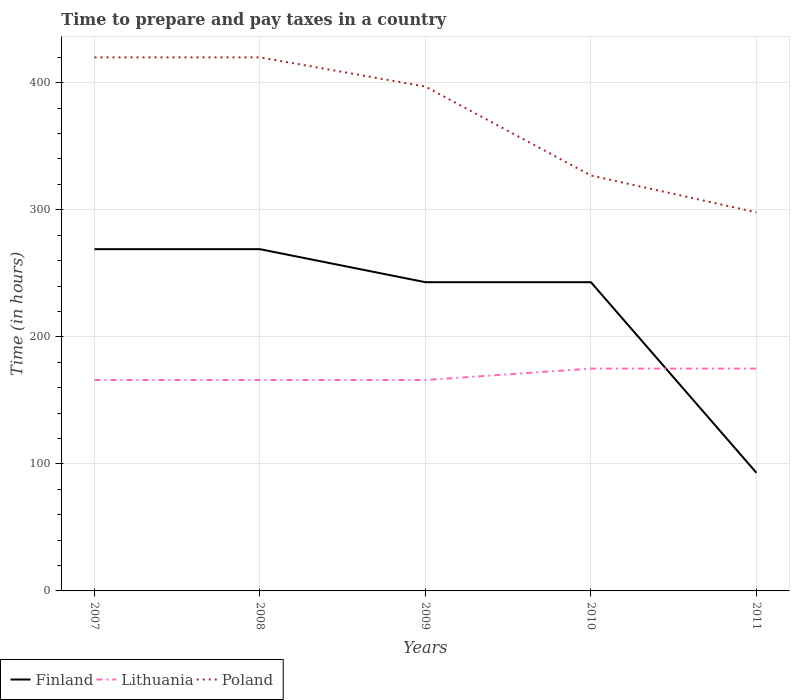How many different coloured lines are there?
Ensure brevity in your answer.  3. Across all years, what is the maximum number of hours required to prepare and pay taxes in Poland?
Keep it short and to the point. 298. In which year was the number of hours required to prepare and pay taxes in Finland maximum?
Your response must be concise. 2011. What is the total number of hours required to prepare and pay taxes in Finland in the graph?
Keep it short and to the point. 0. What is the difference between the highest and the second highest number of hours required to prepare and pay taxes in Poland?
Your response must be concise. 122. What is the difference between the highest and the lowest number of hours required to prepare and pay taxes in Finland?
Keep it short and to the point. 4. How many years are there in the graph?
Keep it short and to the point. 5. Does the graph contain grids?
Offer a terse response. Yes. Where does the legend appear in the graph?
Your answer should be compact. Bottom left. How many legend labels are there?
Ensure brevity in your answer.  3. How are the legend labels stacked?
Your answer should be compact. Horizontal. What is the title of the graph?
Give a very brief answer. Time to prepare and pay taxes in a country. What is the label or title of the X-axis?
Your answer should be compact. Years. What is the label or title of the Y-axis?
Provide a succinct answer. Time (in hours). What is the Time (in hours) in Finland in 2007?
Provide a succinct answer. 269. What is the Time (in hours) of Lithuania in 2007?
Your answer should be very brief. 166. What is the Time (in hours) of Poland in 2007?
Keep it short and to the point. 420. What is the Time (in hours) in Finland in 2008?
Keep it short and to the point. 269. What is the Time (in hours) of Lithuania in 2008?
Your response must be concise. 166. What is the Time (in hours) in Poland in 2008?
Your answer should be very brief. 420. What is the Time (in hours) of Finland in 2009?
Ensure brevity in your answer.  243. What is the Time (in hours) of Lithuania in 2009?
Make the answer very short. 166. What is the Time (in hours) of Poland in 2009?
Offer a very short reply. 397. What is the Time (in hours) of Finland in 2010?
Provide a succinct answer. 243. What is the Time (in hours) in Lithuania in 2010?
Ensure brevity in your answer.  175. What is the Time (in hours) of Poland in 2010?
Give a very brief answer. 327. What is the Time (in hours) of Finland in 2011?
Offer a very short reply. 93. What is the Time (in hours) in Lithuania in 2011?
Your answer should be compact. 175. What is the Time (in hours) in Poland in 2011?
Your response must be concise. 298. Across all years, what is the maximum Time (in hours) in Finland?
Provide a short and direct response. 269. Across all years, what is the maximum Time (in hours) in Lithuania?
Your response must be concise. 175. Across all years, what is the maximum Time (in hours) of Poland?
Your response must be concise. 420. Across all years, what is the minimum Time (in hours) of Finland?
Provide a succinct answer. 93. Across all years, what is the minimum Time (in hours) of Lithuania?
Your response must be concise. 166. Across all years, what is the minimum Time (in hours) in Poland?
Provide a short and direct response. 298. What is the total Time (in hours) of Finland in the graph?
Your response must be concise. 1117. What is the total Time (in hours) of Lithuania in the graph?
Provide a short and direct response. 848. What is the total Time (in hours) in Poland in the graph?
Ensure brevity in your answer.  1862. What is the difference between the Time (in hours) in Finland in 2007 and that in 2008?
Offer a terse response. 0. What is the difference between the Time (in hours) of Finland in 2007 and that in 2009?
Keep it short and to the point. 26. What is the difference between the Time (in hours) of Poland in 2007 and that in 2009?
Make the answer very short. 23. What is the difference between the Time (in hours) of Finland in 2007 and that in 2010?
Your answer should be very brief. 26. What is the difference between the Time (in hours) of Lithuania in 2007 and that in 2010?
Your answer should be compact. -9. What is the difference between the Time (in hours) in Poland in 2007 and that in 2010?
Offer a very short reply. 93. What is the difference between the Time (in hours) in Finland in 2007 and that in 2011?
Provide a short and direct response. 176. What is the difference between the Time (in hours) in Lithuania in 2007 and that in 2011?
Provide a succinct answer. -9. What is the difference between the Time (in hours) of Poland in 2007 and that in 2011?
Your response must be concise. 122. What is the difference between the Time (in hours) in Poland in 2008 and that in 2009?
Keep it short and to the point. 23. What is the difference between the Time (in hours) in Finland in 2008 and that in 2010?
Your response must be concise. 26. What is the difference between the Time (in hours) of Lithuania in 2008 and that in 2010?
Provide a succinct answer. -9. What is the difference between the Time (in hours) in Poland in 2008 and that in 2010?
Your answer should be compact. 93. What is the difference between the Time (in hours) in Finland in 2008 and that in 2011?
Provide a short and direct response. 176. What is the difference between the Time (in hours) in Poland in 2008 and that in 2011?
Give a very brief answer. 122. What is the difference between the Time (in hours) in Finland in 2009 and that in 2010?
Your answer should be very brief. 0. What is the difference between the Time (in hours) of Lithuania in 2009 and that in 2010?
Keep it short and to the point. -9. What is the difference between the Time (in hours) in Poland in 2009 and that in 2010?
Give a very brief answer. 70. What is the difference between the Time (in hours) of Finland in 2009 and that in 2011?
Make the answer very short. 150. What is the difference between the Time (in hours) of Lithuania in 2009 and that in 2011?
Offer a terse response. -9. What is the difference between the Time (in hours) in Finland in 2010 and that in 2011?
Your answer should be compact. 150. What is the difference between the Time (in hours) in Poland in 2010 and that in 2011?
Offer a very short reply. 29. What is the difference between the Time (in hours) of Finland in 2007 and the Time (in hours) of Lithuania in 2008?
Give a very brief answer. 103. What is the difference between the Time (in hours) of Finland in 2007 and the Time (in hours) of Poland in 2008?
Your answer should be compact. -151. What is the difference between the Time (in hours) of Lithuania in 2007 and the Time (in hours) of Poland in 2008?
Offer a terse response. -254. What is the difference between the Time (in hours) of Finland in 2007 and the Time (in hours) of Lithuania in 2009?
Your answer should be very brief. 103. What is the difference between the Time (in hours) in Finland in 2007 and the Time (in hours) in Poland in 2009?
Make the answer very short. -128. What is the difference between the Time (in hours) in Lithuania in 2007 and the Time (in hours) in Poland in 2009?
Give a very brief answer. -231. What is the difference between the Time (in hours) of Finland in 2007 and the Time (in hours) of Lithuania in 2010?
Provide a succinct answer. 94. What is the difference between the Time (in hours) in Finland in 2007 and the Time (in hours) in Poland in 2010?
Your answer should be very brief. -58. What is the difference between the Time (in hours) of Lithuania in 2007 and the Time (in hours) of Poland in 2010?
Ensure brevity in your answer.  -161. What is the difference between the Time (in hours) of Finland in 2007 and the Time (in hours) of Lithuania in 2011?
Give a very brief answer. 94. What is the difference between the Time (in hours) of Finland in 2007 and the Time (in hours) of Poland in 2011?
Provide a short and direct response. -29. What is the difference between the Time (in hours) of Lithuania in 2007 and the Time (in hours) of Poland in 2011?
Provide a short and direct response. -132. What is the difference between the Time (in hours) in Finland in 2008 and the Time (in hours) in Lithuania in 2009?
Provide a short and direct response. 103. What is the difference between the Time (in hours) of Finland in 2008 and the Time (in hours) of Poland in 2009?
Provide a succinct answer. -128. What is the difference between the Time (in hours) in Lithuania in 2008 and the Time (in hours) in Poland in 2009?
Offer a very short reply. -231. What is the difference between the Time (in hours) in Finland in 2008 and the Time (in hours) in Lithuania in 2010?
Keep it short and to the point. 94. What is the difference between the Time (in hours) of Finland in 2008 and the Time (in hours) of Poland in 2010?
Offer a terse response. -58. What is the difference between the Time (in hours) of Lithuania in 2008 and the Time (in hours) of Poland in 2010?
Keep it short and to the point. -161. What is the difference between the Time (in hours) of Finland in 2008 and the Time (in hours) of Lithuania in 2011?
Your answer should be compact. 94. What is the difference between the Time (in hours) of Lithuania in 2008 and the Time (in hours) of Poland in 2011?
Make the answer very short. -132. What is the difference between the Time (in hours) of Finland in 2009 and the Time (in hours) of Poland in 2010?
Offer a very short reply. -84. What is the difference between the Time (in hours) in Lithuania in 2009 and the Time (in hours) in Poland in 2010?
Offer a terse response. -161. What is the difference between the Time (in hours) of Finland in 2009 and the Time (in hours) of Poland in 2011?
Your answer should be very brief. -55. What is the difference between the Time (in hours) of Lithuania in 2009 and the Time (in hours) of Poland in 2011?
Keep it short and to the point. -132. What is the difference between the Time (in hours) of Finland in 2010 and the Time (in hours) of Lithuania in 2011?
Ensure brevity in your answer.  68. What is the difference between the Time (in hours) in Finland in 2010 and the Time (in hours) in Poland in 2011?
Provide a short and direct response. -55. What is the difference between the Time (in hours) of Lithuania in 2010 and the Time (in hours) of Poland in 2011?
Keep it short and to the point. -123. What is the average Time (in hours) in Finland per year?
Your answer should be very brief. 223.4. What is the average Time (in hours) of Lithuania per year?
Keep it short and to the point. 169.6. What is the average Time (in hours) in Poland per year?
Offer a terse response. 372.4. In the year 2007, what is the difference between the Time (in hours) of Finland and Time (in hours) of Lithuania?
Your response must be concise. 103. In the year 2007, what is the difference between the Time (in hours) in Finland and Time (in hours) in Poland?
Make the answer very short. -151. In the year 2007, what is the difference between the Time (in hours) of Lithuania and Time (in hours) of Poland?
Keep it short and to the point. -254. In the year 2008, what is the difference between the Time (in hours) of Finland and Time (in hours) of Lithuania?
Your answer should be compact. 103. In the year 2008, what is the difference between the Time (in hours) of Finland and Time (in hours) of Poland?
Provide a short and direct response. -151. In the year 2008, what is the difference between the Time (in hours) of Lithuania and Time (in hours) of Poland?
Your answer should be compact. -254. In the year 2009, what is the difference between the Time (in hours) in Finland and Time (in hours) in Lithuania?
Ensure brevity in your answer.  77. In the year 2009, what is the difference between the Time (in hours) of Finland and Time (in hours) of Poland?
Offer a terse response. -154. In the year 2009, what is the difference between the Time (in hours) in Lithuania and Time (in hours) in Poland?
Provide a succinct answer. -231. In the year 2010, what is the difference between the Time (in hours) of Finland and Time (in hours) of Lithuania?
Your answer should be compact. 68. In the year 2010, what is the difference between the Time (in hours) in Finland and Time (in hours) in Poland?
Provide a short and direct response. -84. In the year 2010, what is the difference between the Time (in hours) in Lithuania and Time (in hours) in Poland?
Ensure brevity in your answer.  -152. In the year 2011, what is the difference between the Time (in hours) in Finland and Time (in hours) in Lithuania?
Give a very brief answer. -82. In the year 2011, what is the difference between the Time (in hours) of Finland and Time (in hours) of Poland?
Offer a very short reply. -205. In the year 2011, what is the difference between the Time (in hours) of Lithuania and Time (in hours) of Poland?
Ensure brevity in your answer.  -123. What is the ratio of the Time (in hours) in Finland in 2007 to that in 2009?
Ensure brevity in your answer.  1.11. What is the ratio of the Time (in hours) of Poland in 2007 to that in 2009?
Make the answer very short. 1.06. What is the ratio of the Time (in hours) of Finland in 2007 to that in 2010?
Make the answer very short. 1.11. What is the ratio of the Time (in hours) of Lithuania in 2007 to that in 2010?
Offer a very short reply. 0.95. What is the ratio of the Time (in hours) of Poland in 2007 to that in 2010?
Your response must be concise. 1.28. What is the ratio of the Time (in hours) in Finland in 2007 to that in 2011?
Provide a short and direct response. 2.89. What is the ratio of the Time (in hours) in Lithuania in 2007 to that in 2011?
Offer a terse response. 0.95. What is the ratio of the Time (in hours) in Poland in 2007 to that in 2011?
Offer a very short reply. 1.41. What is the ratio of the Time (in hours) of Finland in 2008 to that in 2009?
Provide a succinct answer. 1.11. What is the ratio of the Time (in hours) of Poland in 2008 to that in 2009?
Ensure brevity in your answer.  1.06. What is the ratio of the Time (in hours) of Finland in 2008 to that in 2010?
Your response must be concise. 1.11. What is the ratio of the Time (in hours) of Lithuania in 2008 to that in 2010?
Your answer should be very brief. 0.95. What is the ratio of the Time (in hours) of Poland in 2008 to that in 2010?
Your response must be concise. 1.28. What is the ratio of the Time (in hours) of Finland in 2008 to that in 2011?
Offer a very short reply. 2.89. What is the ratio of the Time (in hours) of Lithuania in 2008 to that in 2011?
Your answer should be compact. 0.95. What is the ratio of the Time (in hours) of Poland in 2008 to that in 2011?
Your answer should be very brief. 1.41. What is the ratio of the Time (in hours) of Lithuania in 2009 to that in 2010?
Make the answer very short. 0.95. What is the ratio of the Time (in hours) of Poland in 2009 to that in 2010?
Your response must be concise. 1.21. What is the ratio of the Time (in hours) of Finland in 2009 to that in 2011?
Your answer should be compact. 2.61. What is the ratio of the Time (in hours) in Lithuania in 2009 to that in 2011?
Make the answer very short. 0.95. What is the ratio of the Time (in hours) in Poland in 2009 to that in 2011?
Offer a terse response. 1.33. What is the ratio of the Time (in hours) in Finland in 2010 to that in 2011?
Make the answer very short. 2.61. What is the ratio of the Time (in hours) of Poland in 2010 to that in 2011?
Keep it short and to the point. 1.1. What is the difference between the highest and the second highest Time (in hours) in Finland?
Make the answer very short. 0. What is the difference between the highest and the second highest Time (in hours) in Poland?
Your response must be concise. 0. What is the difference between the highest and the lowest Time (in hours) in Finland?
Ensure brevity in your answer.  176. What is the difference between the highest and the lowest Time (in hours) of Lithuania?
Provide a succinct answer. 9. What is the difference between the highest and the lowest Time (in hours) in Poland?
Make the answer very short. 122. 